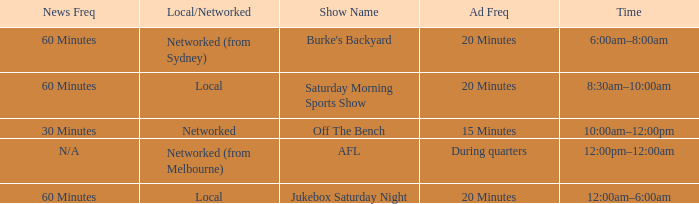What is the ad frequency for the Show Off The Bench? 15 Minutes. 